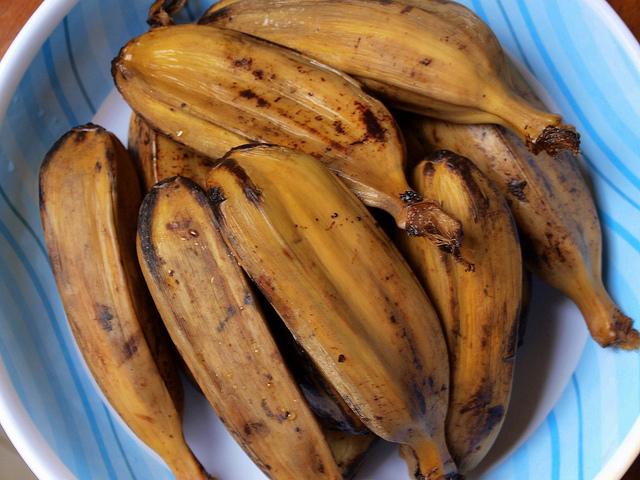What color is the bowl?
Give a very brief answer. Blue. How many plantains are visible?
Keep it brief. 8. How are the bananas?
Keep it brief. Ripe. 